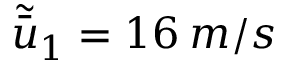Convert formula to latex. <formula><loc_0><loc_0><loc_500><loc_500>\tilde { \bar { u } } _ { 1 } = 1 6 \, m / s</formula> 